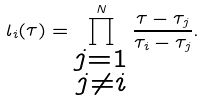<formula> <loc_0><loc_0><loc_500><loc_500>l _ { i } ( \tau ) = \prod ^ { N } _ { \substack { j = 1 \\ j \neq i } } \frac { \tau - \tau _ { j } } { \tau _ { i } - \tau _ { j } } .</formula> 